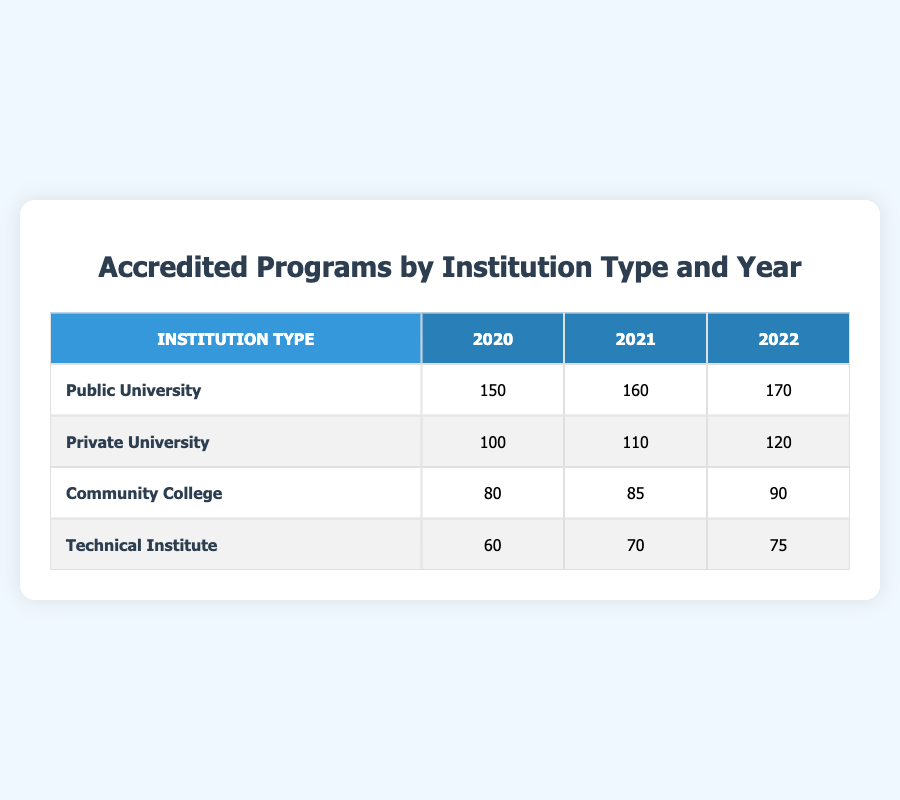What is the number of accredited programs for Public Universities in 2022? Referring to the table, the row for Public Universities in the year 2022 shows that there are 170 accredited programs.
Answer: 170 How many accredited programs did Private Universities have in 2021 compared to 2020? Looking at the table, Private Universities had 110 accredited programs in 2021 and 100 in 2020. The difference is 110 - 100 = 10.
Answer: 10 Which institution type had the least number of accredited programs in 2020? From the table, the Technical Institute had 60 accredited programs, which is fewer than the other institution types: Public University (150), Private University (100), and Community College (80).
Answer: Technical Institute What is the total number of accredited programs for Community Colleges from 2020 to 2022? Summing the accredited programs for Community Colleges over these years: 80 (for 2020) + 85 (for 2021) + 90 (for 2022) = 255.
Answer: 255 Did the number of accredited programs for Technical Institutes decline from 2021 to 2022? Looking at the table, Technical Institutes had 70 accredited programs in 2021 and 75 in 2022, indicating an increase rather than a decline.
Answer: No What is the average number of accredited programs across all institution types for the year 2021? For 2021, the accredited programs are: Public University (160), Private University (110), Community College (85), Technical Institute (70). Adding these gives 160 + 110 + 85 + 70 = 425. The average is 425/4 = 106.25.
Answer: 106.25 Which year saw the highest overall increase in accredited programs across all institution types? Calculating the total accredited programs for each year: In 2020, the total is 150 + 100 + 80 + 60 = 390. In 2021, it is 160 + 110 + 85 + 70 = 425. In 2022, it's 170 + 120 + 90 + 75 = 455. The increase from 2020 to 2021 is 425 - 390 = 35, and from 2021 to 2022 is 455 - 425 = 30. The highest increase was from 2020 to 2021.
Answer: 2021 How many accredited programs were there in total for Public and Private Universities combined in 2022? For 2022, Public Universities had 170 accredited programs and Private Universities had 120. Adding these together gives 170 + 120 = 290.
Answer: 290 